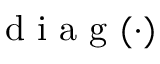Convert formula to latex. <formula><loc_0><loc_0><loc_500><loc_500>d i a g ( \cdot )</formula> 